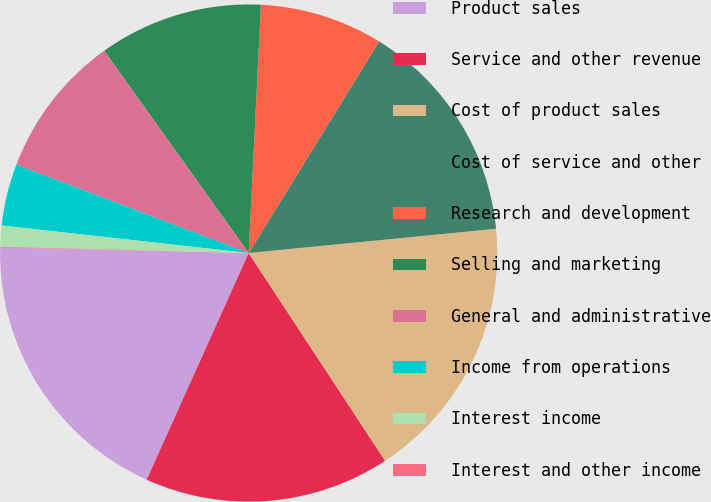Convert chart. <chart><loc_0><loc_0><loc_500><loc_500><pie_chart><fcel>Product sales<fcel>Service and other revenue<fcel>Cost of product sales<fcel>Cost of service and other<fcel>Research and development<fcel>Selling and marketing<fcel>General and administrative<fcel>Income from operations<fcel>Interest income<fcel>Interest and other income<nl><fcel>18.63%<fcel>15.98%<fcel>17.31%<fcel>14.65%<fcel>8.01%<fcel>10.66%<fcel>9.34%<fcel>4.02%<fcel>1.37%<fcel>0.04%<nl></chart> 